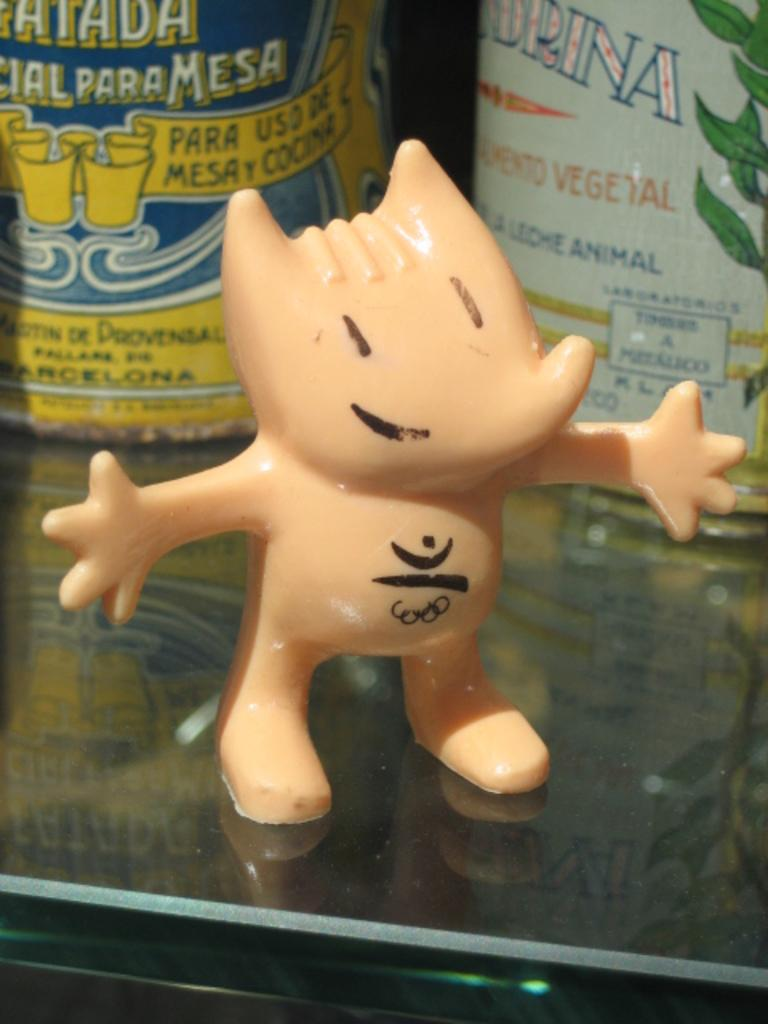What is on the table in the image? There is a toy on the table. What can be seen in the background of the image? There are objects in the background of the image. Can you describe the objects in the background? The objects in the background have text written on them. How many pigs are visible in the image? There are no pigs present in the image. What type of produce can be seen in the image? There is no produce visible in the image. 